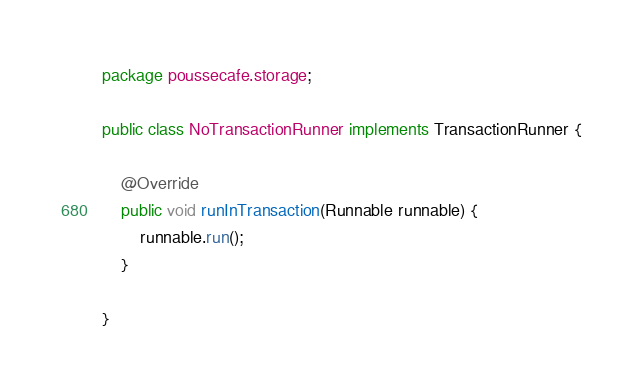<code> <loc_0><loc_0><loc_500><loc_500><_Java_>package poussecafe.storage;

public class NoTransactionRunner implements TransactionRunner {

    @Override
    public void runInTransaction(Runnable runnable) {
        runnable.run();
    }

}
</code> 